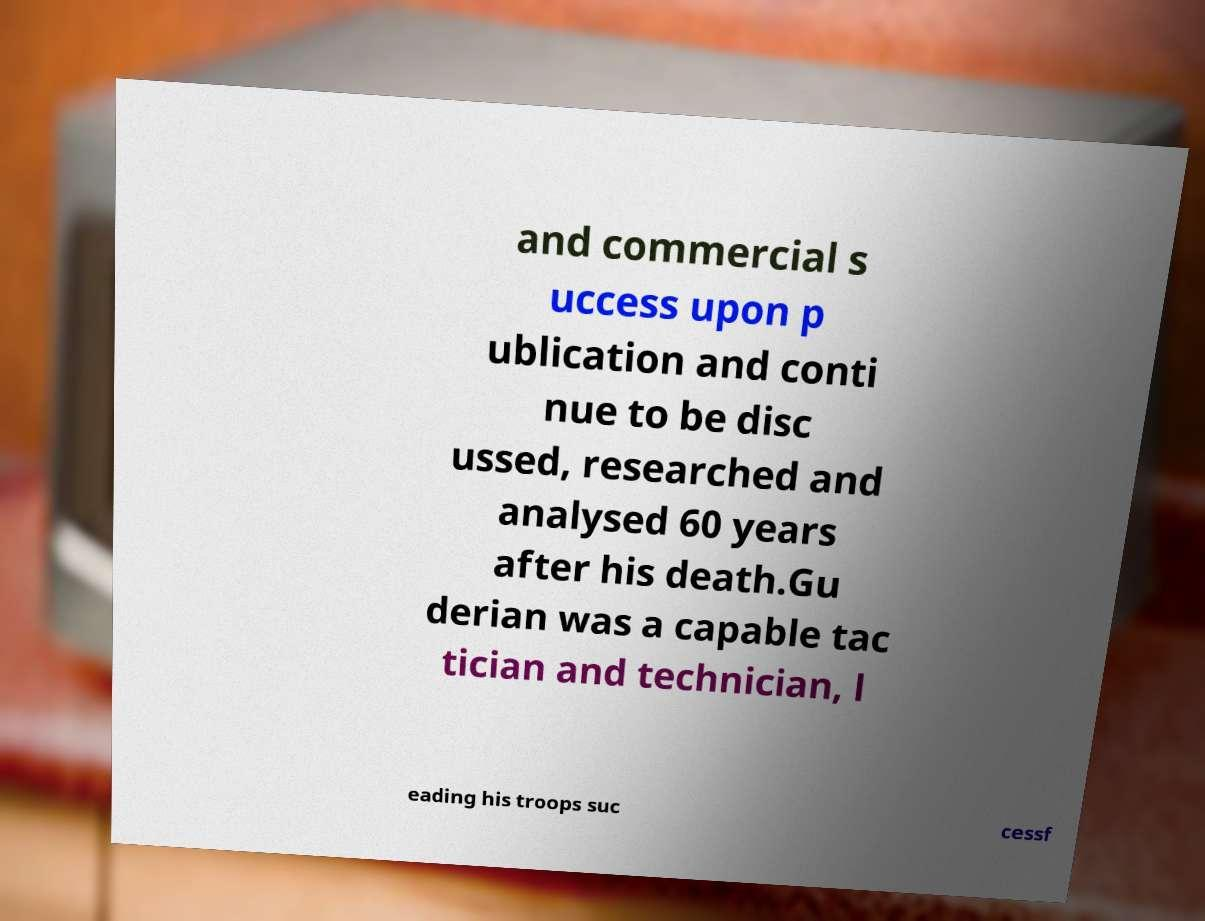What messages or text are displayed in this image? I need them in a readable, typed format. and commercial s uccess upon p ublication and conti nue to be disc ussed, researched and analysed 60 years after his death.Gu derian was a capable tac tician and technician, l eading his troops suc cessf 